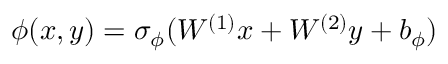Convert formula to latex. <formula><loc_0><loc_0><loc_500><loc_500>\phi ( x , y ) = \sigma _ { \phi } ( W ^ { ( 1 ) } x + W ^ { ( 2 ) } y + b _ { \phi } )</formula> 